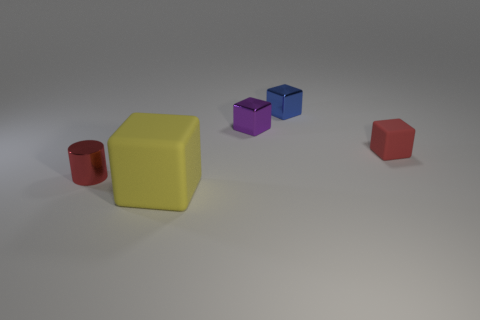Is the number of tiny matte objects that are in front of the yellow rubber cube the same as the number of tiny brown spheres?
Your response must be concise. Yes. Do the matte thing that is on the left side of the blue object and the tiny purple shiny block have the same size?
Provide a succinct answer. No. There is a purple thing; how many tiny things are behind it?
Your answer should be compact. 1. There is a small object that is left of the blue block and on the right side of the tiny cylinder; what is it made of?
Offer a terse response. Metal. What number of big things are either purple metallic objects or brown shiny cylinders?
Ensure brevity in your answer.  0. What size is the yellow matte cube?
Provide a short and direct response. Large. What shape is the purple thing?
Ensure brevity in your answer.  Cube. Is there any other thing that has the same shape as the small red metal thing?
Your answer should be very brief. No. Is the number of tiny red cylinders behind the small red cylinder less than the number of big yellow metallic cylinders?
Offer a terse response. No. There is a shiny thing that is left of the purple metallic object; is its color the same as the tiny matte block?
Your response must be concise. Yes. 